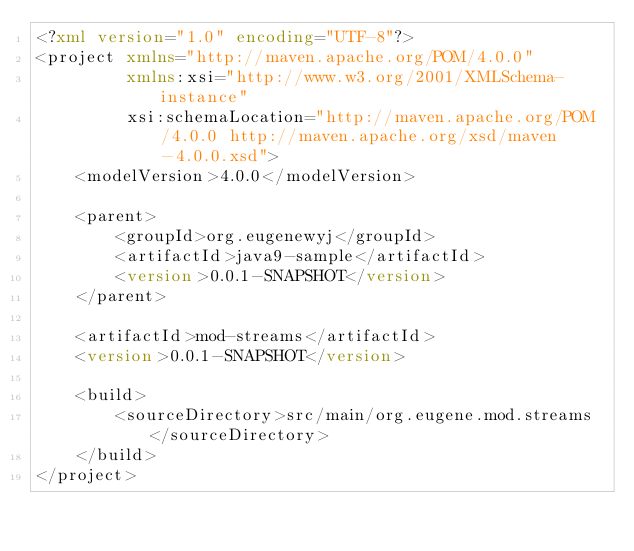<code> <loc_0><loc_0><loc_500><loc_500><_XML_><?xml version="1.0" encoding="UTF-8"?>
<project xmlns="http://maven.apache.org/POM/4.0.0"
         xmlns:xsi="http://www.w3.org/2001/XMLSchema-instance"
         xsi:schemaLocation="http://maven.apache.org/POM/4.0.0 http://maven.apache.org/xsd/maven-4.0.0.xsd">
    <modelVersion>4.0.0</modelVersion>

    <parent>
        <groupId>org.eugenewyj</groupId>
        <artifactId>java9-sample</artifactId>
        <version>0.0.1-SNAPSHOT</version>
    </parent>

    <artifactId>mod-streams</artifactId>
    <version>0.0.1-SNAPSHOT</version>

    <build>
        <sourceDirectory>src/main/org.eugene.mod.streams</sourceDirectory>
    </build>
</project></code> 